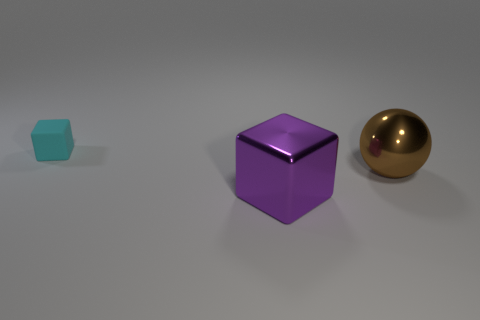Subtract 2 blocks. How many blocks are left? 0 Subtract 0 cyan cylinders. How many objects are left? 3 Subtract all balls. How many objects are left? 2 Subtract all red spheres. Subtract all blue cylinders. How many spheres are left? 1 Subtract all blue cylinders. How many yellow cubes are left? 0 Subtract all big balls. Subtract all purple metal things. How many objects are left? 1 Add 1 big purple metal blocks. How many big purple metal blocks are left? 2 Add 3 purple shiny objects. How many purple shiny objects exist? 4 Add 2 large purple blocks. How many objects exist? 5 